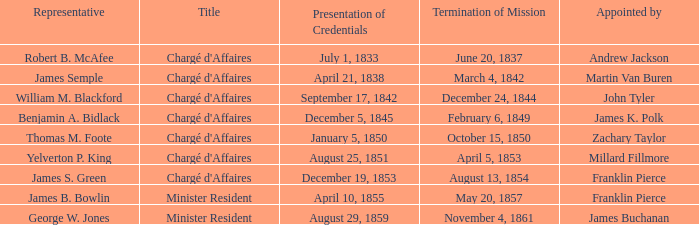Write the full table. {'header': ['Representative', 'Title', 'Presentation of Credentials', 'Termination of Mission', 'Appointed by'], 'rows': [['Robert B. McAfee', "Chargé d'Affaires", 'July 1, 1833', 'June 20, 1837', 'Andrew Jackson'], ['James Semple', "Chargé d'Affaires", 'April 21, 1838', 'March 4, 1842', 'Martin Van Buren'], ['William M. Blackford', "Chargé d'Affaires", 'September 17, 1842', 'December 24, 1844', 'John Tyler'], ['Benjamin A. Bidlack', "Chargé d'Affaires", 'December 5, 1845', 'February 6, 1849', 'James K. Polk'], ['Thomas M. Foote', "Chargé d'Affaires", 'January 5, 1850', 'October 15, 1850', 'Zachary Taylor'], ['Yelverton P. King', "Chargé d'Affaires", 'August 25, 1851', 'April 5, 1853', 'Millard Fillmore'], ['James S. Green', "Chargé d'Affaires", 'December 19, 1853', 'August 13, 1854', 'Franklin Pierce'], ['James B. Bowlin', 'Minister Resident', 'April 10, 1855', 'May 20, 1857', 'Franklin Pierce'], ['George W. Jones', 'Minister Resident', 'August 29, 1859', 'November 4, 1861', 'James Buchanan']]} What Title has a Termination of Mission of November 4, 1861? Minister Resident. 